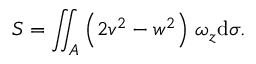<formula> <loc_0><loc_0><loc_500><loc_500>S = \iint _ { A } \left ( 2 v ^ { 2 } - w ^ { 2 } \right ) \, \omega _ { z } d \sigma .</formula> 